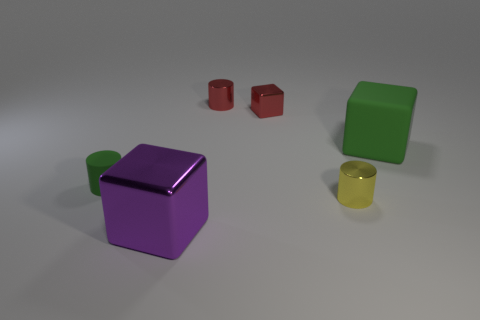Subtract all large matte cubes. How many cubes are left? 2 Subtract 3 cylinders. How many cylinders are left? 0 Subtract all yellow cylinders. Subtract all gray blocks. How many cylinders are left? 2 Subtract all brown cylinders. How many cyan cubes are left? 0 Subtract all small metal things. Subtract all small yellow objects. How many objects are left? 2 Add 3 yellow metal things. How many yellow metal things are left? 4 Add 2 small cylinders. How many small cylinders exist? 5 Add 4 large green matte balls. How many objects exist? 10 Subtract 0 blue cylinders. How many objects are left? 6 